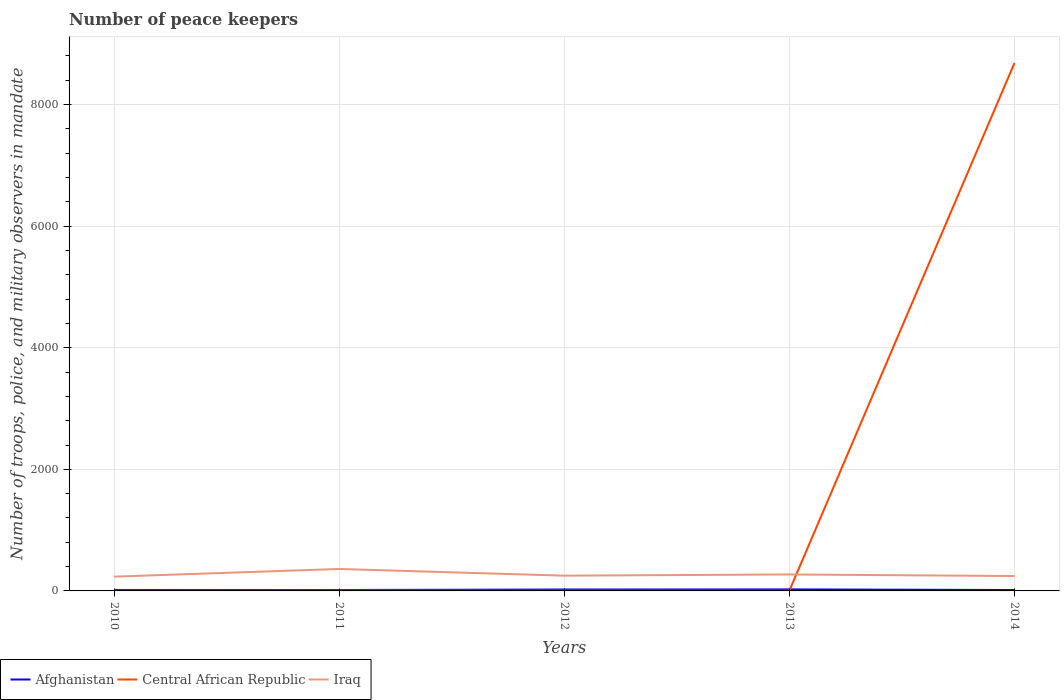How many different coloured lines are there?
Offer a very short reply. 3. Does the line corresponding to Iraq intersect with the line corresponding to Central African Republic?
Your response must be concise. Yes. Across all years, what is the maximum number of peace keepers in in Iraq?
Provide a short and direct response. 235. In which year was the number of peace keepers in in Iraq maximum?
Provide a succinct answer. 2010. What is the total number of peace keepers in in Iraq in the graph?
Provide a short and direct response. -126. What is the difference between the highest and the second highest number of peace keepers in in Central African Republic?
Your answer should be very brief. 8682. Is the number of peace keepers in in Afghanistan strictly greater than the number of peace keepers in in Iraq over the years?
Offer a terse response. Yes. How many lines are there?
Keep it short and to the point. 3. What is the title of the graph?
Make the answer very short. Number of peace keepers. Does "Spain" appear as one of the legend labels in the graph?
Your response must be concise. No. What is the label or title of the Y-axis?
Your answer should be compact. Number of troops, police, and military observers in mandate. What is the Number of troops, police, and military observers in mandate in Afghanistan in 2010?
Offer a terse response. 16. What is the Number of troops, police, and military observers in mandate of Central African Republic in 2010?
Make the answer very short. 3. What is the Number of troops, police, and military observers in mandate of Iraq in 2010?
Offer a very short reply. 235. What is the Number of troops, police, and military observers in mandate in Afghanistan in 2011?
Your response must be concise. 15. What is the Number of troops, police, and military observers in mandate of Central African Republic in 2011?
Offer a very short reply. 4. What is the Number of troops, police, and military observers in mandate in Iraq in 2011?
Your answer should be very brief. 361. What is the Number of troops, police, and military observers in mandate in Afghanistan in 2012?
Your answer should be compact. 23. What is the Number of troops, police, and military observers in mandate of Iraq in 2012?
Provide a succinct answer. 251. What is the Number of troops, police, and military observers in mandate in Afghanistan in 2013?
Give a very brief answer. 25. What is the Number of troops, police, and military observers in mandate of Iraq in 2013?
Make the answer very short. 271. What is the Number of troops, police, and military observers in mandate of Afghanistan in 2014?
Offer a very short reply. 15. What is the Number of troops, police, and military observers in mandate in Central African Republic in 2014?
Provide a short and direct response. 8685. What is the Number of troops, police, and military observers in mandate in Iraq in 2014?
Make the answer very short. 245. Across all years, what is the maximum Number of troops, police, and military observers in mandate of Afghanistan?
Keep it short and to the point. 25. Across all years, what is the maximum Number of troops, police, and military observers in mandate in Central African Republic?
Provide a short and direct response. 8685. Across all years, what is the maximum Number of troops, police, and military observers in mandate in Iraq?
Offer a very short reply. 361. Across all years, what is the minimum Number of troops, police, and military observers in mandate of Iraq?
Offer a terse response. 235. What is the total Number of troops, police, and military observers in mandate of Afghanistan in the graph?
Provide a succinct answer. 94. What is the total Number of troops, police, and military observers in mandate in Central African Republic in the graph?
Give a very brief answer. 8700. What is the total Number of troops, police, and military observers in mandate in Iraq in the graph?
Provide a succinct answer. 1363. What is the difference between the Number of troops, police, and military observers in mandate in Iraq in 2010 and that in 2011?
Keep it short and to the point. -126. What is the difference between the Number of troops, police, and military observers in mandate in Afghanistan in 2010 and that in 2012?
Ensure brevity in your answer.  -7. What is the difference between the Number of troops, police, and military observers in mandate in Iraq in 2010 and that in 2012?
Offer a terse response. -16. What is the difference between the Number of troops, police, and military observers in mandate in Iraq in 2010 and that in 2013?
Offer a very short reply. -36. What is the difference between the Number of troops, police, and military observers in mandate of Afghanistan in 2010 and that in 2014?
Offer a terse response. 1. What is the difference between the Number of troops, police, and military observers in mandate in Central African Republic in 2010 and that in 2014?
Offer a very short reply. -8682. What is the difference between the Number of troops, police, and military observers in mandate in Iraq in 2010 and that in 2014?
Give a very brief answer. -10. What is the difference between the Number of troops, police, and military observers in mandate of Afghanistan in 2011 and that in 2012?
Provide a short and direct response. -8. What is the difference between the Number of troops, police, and military observers in mandate in Iraq in 2011 and that in 2012?
Offer a terse response. 110. What is the difference between the Number of troops, police, and military observers in mandate in Central African Republic in 2011 and that in 2013?
Make the answer very short. 0. What is the difference between the Number of troops, police, and military observers in mandate of Iraq in 2011 and that in 2013?
Offer a very short reply. 90. What is the difference between the Number of troops, police, and military observers in mandate of Central African Republic in 2011 and that in 2014?
Your answer should be compact. -8681. What is the difference between the Number of troops, police, and military observers in mandate in Iraq in 2011 and that in 2014?
Your answer should be very brief. 116. What is the difference between the Number of troops, police, and military observers in mandate in Central African Republic in 2012 and that in 2014?
Provide a succinct answer. -8681. What is the difference between the Number of troops, police, and military observers in mandate of Iraq in 2012 and that in 2014?
Make the answer very short. 6. What is the difference between the Number of troops, police, and military observers in mandate in Afghanistan in 2013 and that in 2014?
Offer a terse response. 10. What is the difference between the Number of troops, police, and military observers in mandate of Central African Republic in 2013 and that in 2014?
Provide a succinct answer. -8681. What is the difference between the Number of troops, police, and military observers in mandate of Iraq in 2013 and that in 2014?
Ensure brevity in your answer.  26. What is the difference between the Number of troops, police, and military observers in mandate in Afghanistan in 2010 and the Number of troops, police, and military observers in mandate in Iraq in 2011?
Keep it short and to the point. -345. What is the difference between the Number of troops, police, and military observers in mandate of Central African Republic in 2010 and the Number of troops, police, and military observers in mandate of Iraq in 2011?
Make the answer very short. -358. What is the difference between the Number of troops, police, and military observers in mandate of Afghanistan in 2010 and the Number of troops, police, and military observers in mandate of Central African Republic in 2012?
Offer a terse response. 12. What is the difference between the Number of troops, police, and military observers in mandate in Afghanistan in 2010 and the Number of troops, police, and military observers in mandate in Iraq in 2012?
Provide a succinct answer. -235. What is the difference between the Number of troops, police, and military observers in mandate of Central African Republic in 2010 and the Number of troops, police, and military observers in mandate of Iraq in 2012?
Give a very brief answer. -248. What is the difference between the Number of troops, police, and military observers in mandate of Afghanistan in 2010 and the Number of troops, police, and military observers in mandate of Iraq in 2013?
Ensure brevity in your answer.  -255. What is the difference between the Number of troops, police, and military observers in mandate in Central African Republic in 2010 and the Number of troops, police, and military observers in mandate in Iraq in 2013?
Offer a very short reply. -268. What is the difference between the Number of troops, police, and military observers in mandate of Afghanistan in 2010 and the Number of troops, police, and military observers in mandate of Central African Republic in 2014?
Ensure brevity in your answer.  -8669. What is the difference between the Number of troops, police, and military observers in mandate of Afghanistan in 2010 and the Number of troops, police, and military observers in mandate of Iraq in 2014?
Keep it short and to the point. -229. What is the difference between the Number of troops, police, and military observers in mandate in Central African Republic in 2010 and the Number of troops, police, and military observers in mandate in Iraq in 2014?
Make the answer very short. -242. What is the difference between the Number of troops, police, and military observers in mandate of Afghanistan in 2011 and the Number of troops, police, and military observers in mandate of Iraq in 2012?
Your answer should be very brief. -236. What is the difference between the Number of troops, police, and military observers in mandate in Central African Republic in 2011 and the Number of troops, police, and military observers in mandate in Iraq in 2012?
Your response must be concise. -247. What is the difference between the Number of troops, police, and military observers in mandate in Afghanistan in 2011 and the Number of troops, police, and military observers in mandate in Central African Republic in 2013?
Your response must be concise. 11. What is the difference between the Number of troops, police, and military observers in mandate in Afghanistan in 2011 and the Number of troops, police, and military observers in mandate in Iraq in 2013?
Keep it short and to the point. -256. What is the difference between the Number of troops, police, and military observers in mandate of Central African Republic in 2011 and the Number of troops, police, and military observers in mandate of Iraq in 2013?
Your answer should be compact. -267. What is the difference between the Number of troops, police, and military observers in mandate in Afghanistan in 2011 and the Number of troops, police, and military observers in mandate in Central African Republic in 2014?
Give a very brief answer. -8670. What is the difference between the Number of troops, police, and military observers in mandate of Afghanistan in 2011 and the Number of troops, police, and military observers in mandate of Iraq in 2014?
Offer a very short reply. -230. What is the difference between the Number of troops, police, and military observers in mandate of Central African Republic in 2011 and the Number of troops, police, and military observers in mandate of Iraq in 2014?
Provide a short and direct response. -241. What is the difference between the Number of troops, police, and military observers in mandate in Afghanistan in 2012 and the Number of troops, police, and military observers in mandate in Iraq in 2013?
Offer a terse response. -248. What is the difference between the Number of troops, police, and military observers in mandate of Central African Republic in 2012 and the Number of troops, police, and military observers in mandate of Iraq in 2013?
Your response must be concise. -267. What is the difference between the Number of troops, police, and military observers in mandate in Afghanistan in 2012 and the Number of troops, police, and military observers in mandate in Central African Republic in 2014?
Ensure brevity in your answer.  -8662. What is the difference between the Number of troops, police, and military observers in mandate of Afghanistan in 2012 and the Number of troops, police, and military observers in mandate of Iraq in 2014?
Your answer should be very brief. -222. What is the difference between the Number of troops, police, and military observers in mandate of Central African Republic in 2012 and the Number of troops, police, and military observers in mandate of Iraq in 2014?
Offer a very short reply. -241. What is the difference between the Number of troops, police, and military observers in mandate of Afghanistan in 2013 and the Number of troops, police, and military observers in mandate of Central African Republic in 2014?
Your response must be concise. -8660. What is the difference between the Number of troops, police, and military observers in mandate in Afghanistan in 2013 and the Number of troops, police, and military observers in mandate in Iraq in 2014?
Give a very brief answer. -220. What is the difference between the Number of troops, police, and military observers in mandate of Central African Republic in 2013 and the Number of troops, police, and military observers in mandate of Iraq in 2014?
Offer a terse response. -241. What is the average Number of troops, police, and military observers in mandate of Afghanistan per year?
Your answer should be compact. 18.8. What is the average Number of troops, police, and military observers in mandate of Central African Republic per year?
Your answer should be compact. 1740. What is the average Number of troops, police, and military observers in mandate of Iraq per year?
Ensure brevity in your answer.  272.6. In the year 2010, what is the difference between the Number of troops, police, and military observers in mandate of Afghanistan and Number of troops, police, and military observers in mandate of Iraq?
Ensure brevity in your answer.  -219. In the year 2010, what is the difference between the Number of troops, police, and military observers in mandate in Central African Republic and Number of troops, police, and military observers in mandate in Iraq?
Make the answer very short. -232. In the year 2011, what is the difference between the Number of troops, police, and military observers in mandate of Afghanistan and Number of troops, police, and military observers in mandate of Central African Republic?
Offer a terse response. 11. In the year 2011, what is the difference between the Number of troops, police, and military observers in mandate in Afghanistan and Number of troops, police, and military observers in mandate in Iraq?
Offer a very short reply. -346. In the year 2011, what is the difference between the Number of troops, police, and military observers in mandate of Central African Republic and Number of troops, police, and military observers in mandate of Iraq?
Give a very brief answer. -357. In the year 2012, what is the difference between the Number of troops, police, and military observers in mandate in Afghanistan and Number of troops, police, and military observers in mandate in Central African Republic?
Make the answer very short. 19. In the year 2012, what is the difference between the Number of troops, police, and military observers in mandate of Afghanistan and Number of troops, police, and military observers in mandate of Iraq?
Provide a succinct answer. -228. In the year 2012, what is the difference between the Number of troops, police, and military observers in mandate in Central African Republic and Number of troops, police, and military observers in mandate in Iraq?
Give a very brief answer. -247. In the year 2013, what is the difference between the Number of troops, police, and military observers in mandate in Afghanistan and Number of troops, police, and military observers in mandate in Central African Republic?
Provide a short and direct response. 21. In the year 2013, what is the difference between the Number of troops, police, and military observers in mandate in Afghanistan and Number of troops, police, and military observers in mandate in Iraq?
Keep it short and to the point. -246. In the year 2013, what is the difference between the Number of troops, police, and military observers in mandate of Central African Republic and Number of troops, police, and military observers in mandate of Iraq?
Give a very brief answer. -267. In the year 2014, what is the difference between the Number of troops, police, and military observers in mandate of Afghanistan and Number of troops, police, and military observers in mandate of Central African Republic?
Offer a terse response. -8670. In the year 2014, what is the difference between the Number of troops, police, and military observers in mandate in Afghanistan and Number of troops, police, and military observers in mandate in Iraq?
Give a very brief answer. -230. In the year 2014, what is the difference between the Number of troops, police, and military observers in mandate in Central African Republic and Number of troops, police, and military observers in mandate in Iraq?
Make the answer very short. 8440. What is the ratio of the Number of troops, police, and military observers in mandate in Afghanistan in 2010 to that in 2011?
Ensure brevity in your answer.  1.07. What is the ratio of the Number of troops, police, and military observers in mandate of Iraq in 2010 to that in 2011?
Your answer should be very brief. 0.65. What is the ratio of the Number of troops, police, and military observers in mandate in Afghanistan in 2010 to that in 2012?
Ensure brevity in your answer.  0.7. What is the ratio of the Number of troops, police, and military observers in mandate of Central African Republic in 2010 to that in 2012?
Your answer should be compact. 0.75. What is the ratio of the Number of troops, police, and military observers in mandate in Iraq in 2010 to that in 2012?
Your answer should be very brief. 0.94. What is the ratio of the Number of troops, police, and military observers in mandate in Afghanistan in 2010 to that in 2013?
Give a very brief answer. 0.64. What is the ratio of the Number of troops, police, and military observers in mandate of Central African Republic in 2010 to that in 2013?
Ensure brevity in your answer.  0.75. What is the ratio of the Number of troops, police, and military observers in mandate in Iraq in 2010 to that in 2013?
Give a very brief answer. 0.87. What is the ratio of the Number of troops, police, and military observers in mandate of Afghanistan in 2010 to that in 2014?
Ensure brevity in your answer.  1.07. What is the ratio of the Number of troops, police, and military observers in mandate of Iraq in 2010 to that in 2014?
Your answer should be very brief. 0.96. What is the ratio of the Number of troops, police, and military observers in mandate in Afghanistan in 2011 to that in 2012?
Offer a terse response. 0.65. What is the ratio of the Number of troops, police, and military observers in mandate of Central African Republic in 2011 to that in 2012?
Give a very brief answer. 1. What is the ratio of the Number of troops, police, and military observers in mandate in Iraq in 2011 to that in 2012?
Provide a succinct answer. 1.44. What is the ratio of the Number of troops, police, and military observers in mandate in Afghanistan in 2011 to that in 2013?
Offer a very short reply. 0.6. What is the ratio of the Number of troops, police, and military observers in mandate of Iraq in 2011 to that in 2013?
Your answer should be compact. 1.33. What is the ratio of the Number of troops, police, and military observers in mandate in Iraq in 2011 to that in 2014?
Offer a terse response. 1.47. What is the ratio of the Number of troops, police, and military observers in mandate in Afghanistan in 2012 to that in 2013?
Offer a terse response. 0.92. What is the ratio of the Number of troops, police, and military observers in mandate of Iraq in 2012 to that in 2013?
Give a very brief answer. 0.93. What is the ratio of the Number of troops, police, and military observers in mandate in Afghanistan in 2012 to that in 2014?
Make the answer very short. 1.53. What is the ratio of the Number of troops, police, and military observers in mandate of Iraq in 2012 to that in 2014?
Your answer should be compact. 1.02. What is the ratio of the Number of troops, police, and military observers in mandate of Iraq in 2013 to that in 2014?
Your answer should be compact. 1.11. What is the difference between the highest and the second highest Number of troops, police, and military observers in mandate in Central African Republic?
Offer a very short reply. 8681. What is the difference between the highest and the lowest Number of troops, police, and military observers in mandate of Central African Republic?
Make the answer very short. 8682. What is the difference between the highest and the lowest Number of troops, police, and military observers in mandate of Iraq?
Offer a very short reply. 126. 